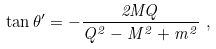Convert formula to latex. <formula><loc_0><loc_0><loc_500><loc_500>\tan \theta ^ { \prime } = - { \frac { 2 M Q } { Q ^ { 2 } - M ^ { 2 } + m ^ { 2 } } } \ ,</formula> 